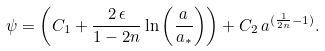<formula> <loc_0><loc_0><loc_500><loc_500>\psi = \left ( C _ { 1 } + \frac { 2 \, \epsilon } { 1 - 2 n } \ln \left ( \frac { a } { a _ { \ast } } \right ) \right ) + C _ { 2 } \, a ^ { ( \frac { 1 } { 2 n } - 1 ) } .</formula> 